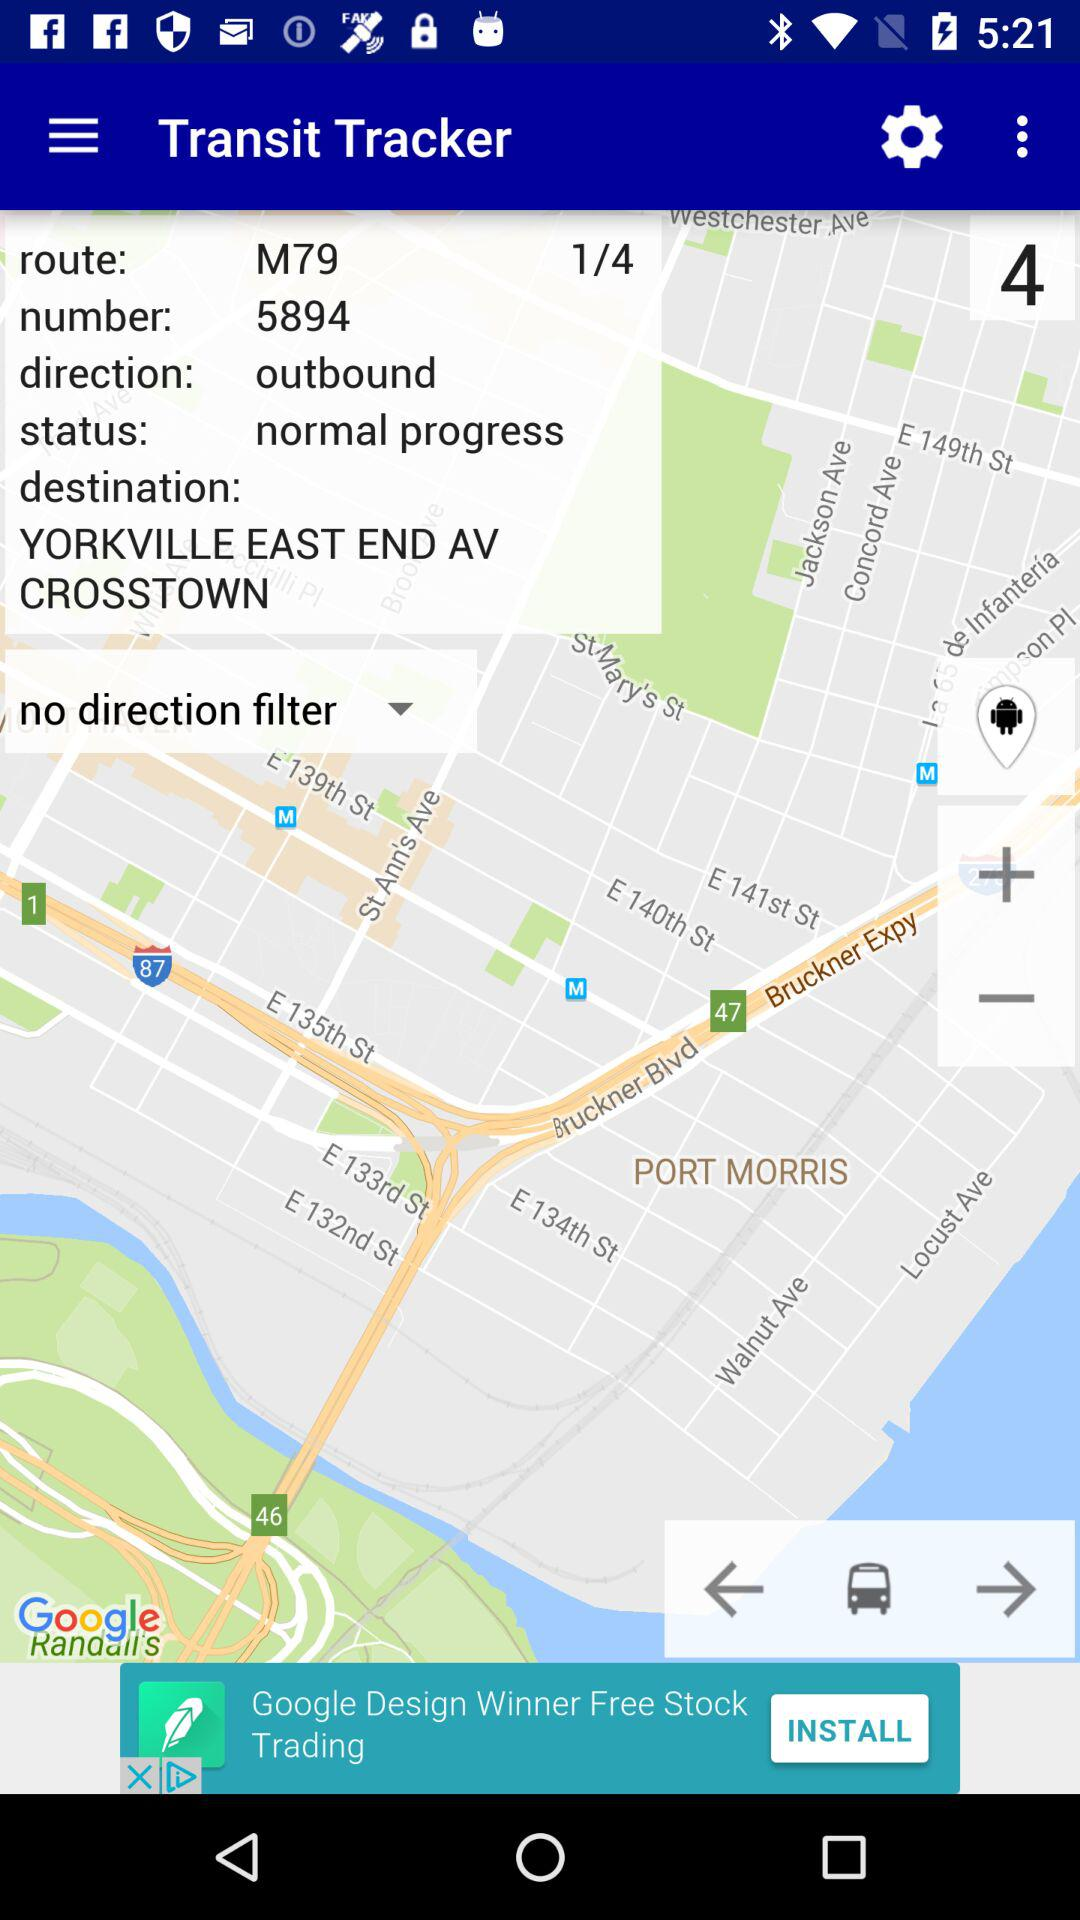How many pages are there in total? There are 4 pages in total. 